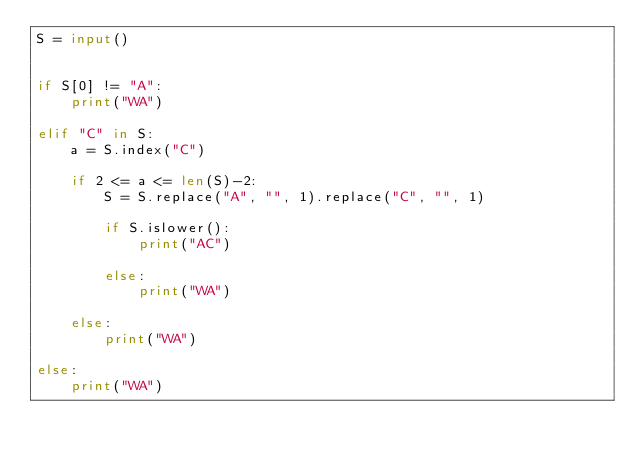<code> <loc_0><loc_0><loc_500><loc_500><_Python_>S = input()
 
 
if S[0] != "A":
    print("WA")
 
elif "C" in S:
    a = S.index("C")
 
    if 2 <= a <= len(S)-2:
        S = S.replace("A", "", 1).replace("C", "", 1)
        
        if S.islower():
            print("AC")
        
        else:
            print("WA")
 
    else:
        print("WA")
 
else:
    print("WA")</code> 